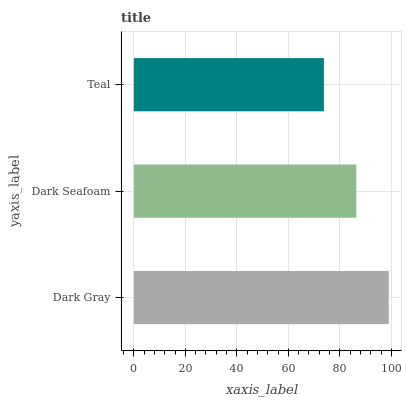Is Teal the minimum?
Answer yes or no. Yes. Is Dark Gray the maximum?
Answer yes or no. Yes. Is Dark Seafoam the minimum?
Answer yes or no. No. Is Dark Seafoam the maximum?
Answer yes or no. No. Is Dark Gray greater than Dark Seafoam?
Answer yes or no. Yes. Is Dark Seafoam less than Dark Gray?
Answer yes or no. Yes. Is Dark Seafoam greater than Dark Gray?
Answer yes or no. No. Is Dark Gray less than Dark Seafoam?
Answer yes or no. No. Is Dark Seafoam the high median?
Answer yes or no. Yes. Is Dark Seafoam the low median?
Answer yes or no. Yes. Is Teal the high median?
Answer yes or no. No. Is Dark Gray the low median?
Answer yes or no. No. 